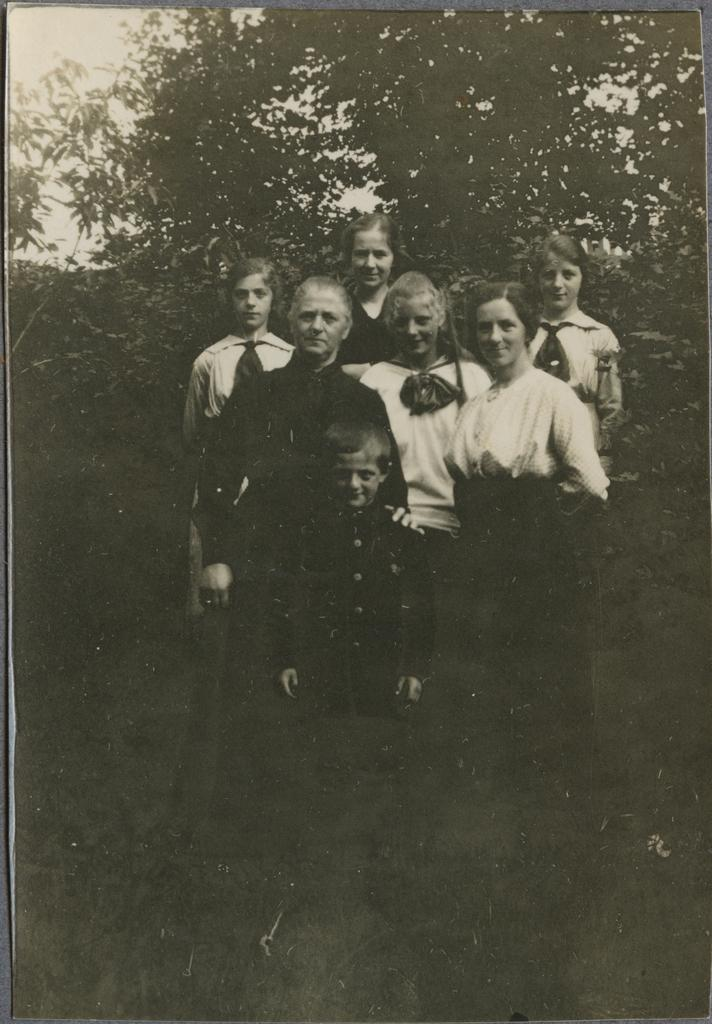What is the color scheme of the image? The image is black and white. What can be seen in the image? There is a group of people in the image. What are the people doing in the image? The people are standing and smiling. What type of natural environment is visible in the image? There are trees in the image. What is visible in the background of the image? The sky is visible in the background of the image. What type of potato is being used as a record in the image? There is no potato or record present in the image; it features a group of people standing and smiling. Where is the library located in the image? There is no library present in the image. 